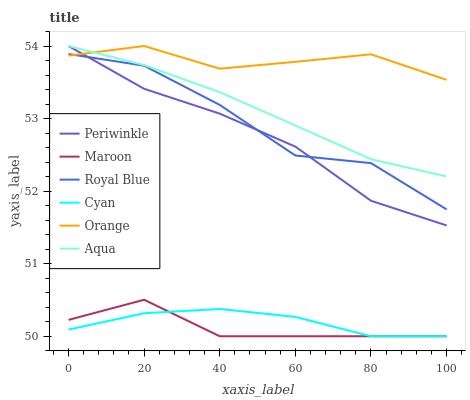Does Royal Blue have the minimum area under the curve?
Answer yes or no. No. Does Royal Blue have the maximum area under the curve?
Answer yes or no. No. Is Maroon the smoothest?
Answer yes or no. No. Is Maroon the roughest?
Answer yes or no. No. Does Royal Blue have the lowest value?
Answer yes or no. No. Does Maroon have the highest value?
Answer yes or no. No. Is Cyan less than Royal Blue?
Answer yes or no. Yes. Is Periwinkle greater than Cyan?
Answer yes or no. Yes. Does Cyan intersect Royal Blue?
Answer yes or no. No. 